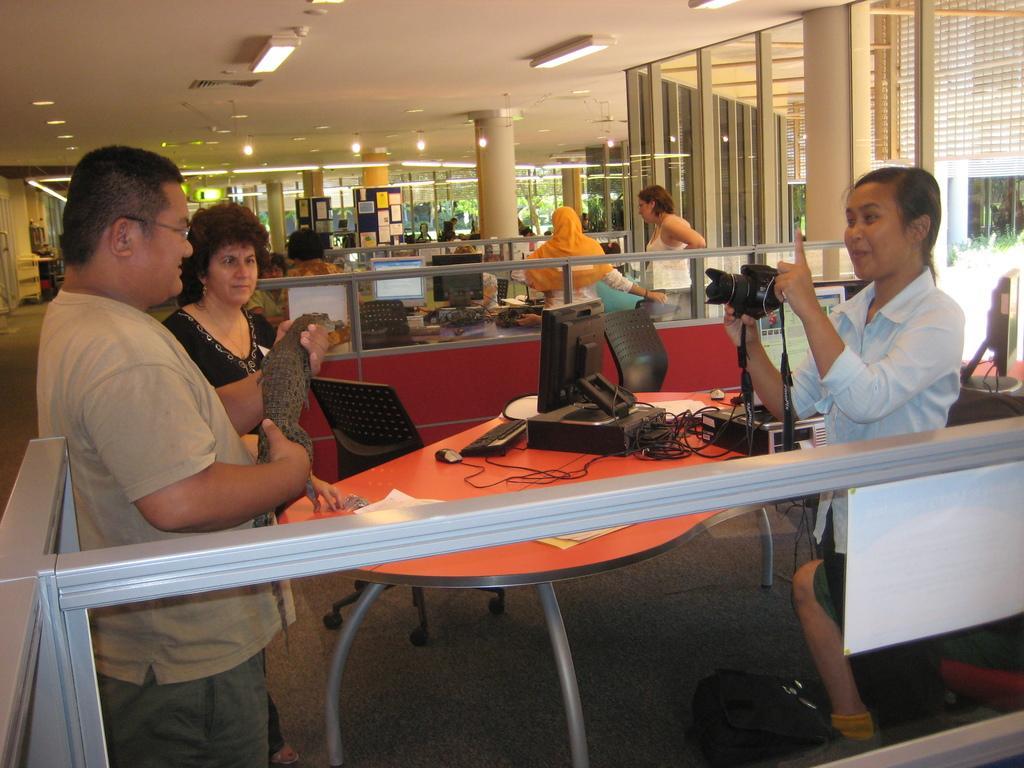Can you describe this image briefly? In this image i can see few people standing, the man is holding a crocodile in his hand, the woman in the right corner is holding a camera in her hand. In the background i can see few monitors, a pillar and the roof. 